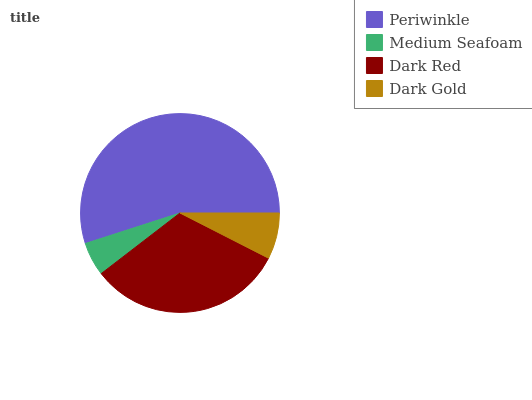Is Medium Seafoam the minimum?
Answer yes or no. Yes. Is Periwinkle the maximum?
Answer yes or no. Yes. Is Dark Red the minimum?
Answer yes or no. No. Is Dark Red the maximum?
Answer yes or no. No. Is Dark Red greater than Medium Seafoam?
Answer yes or no. Yes. Is Medium Seafoam less than Dark Red?
Answer yes or no. Yes. Is Medium Seafoam greater than Dark Red?
Answer yes or no. No. Is Dark Red less than Medium Seafoam?
Answer yes or no. No. Is Dark Red the high median?
Answer yes or no. Yes. Is Dark Gold the low median?
Answer yes or no. Yes. Is Dark Gold the high median?
Answer yes or no. No. Is Dark Red the low median?
Answer yes or no. No. 